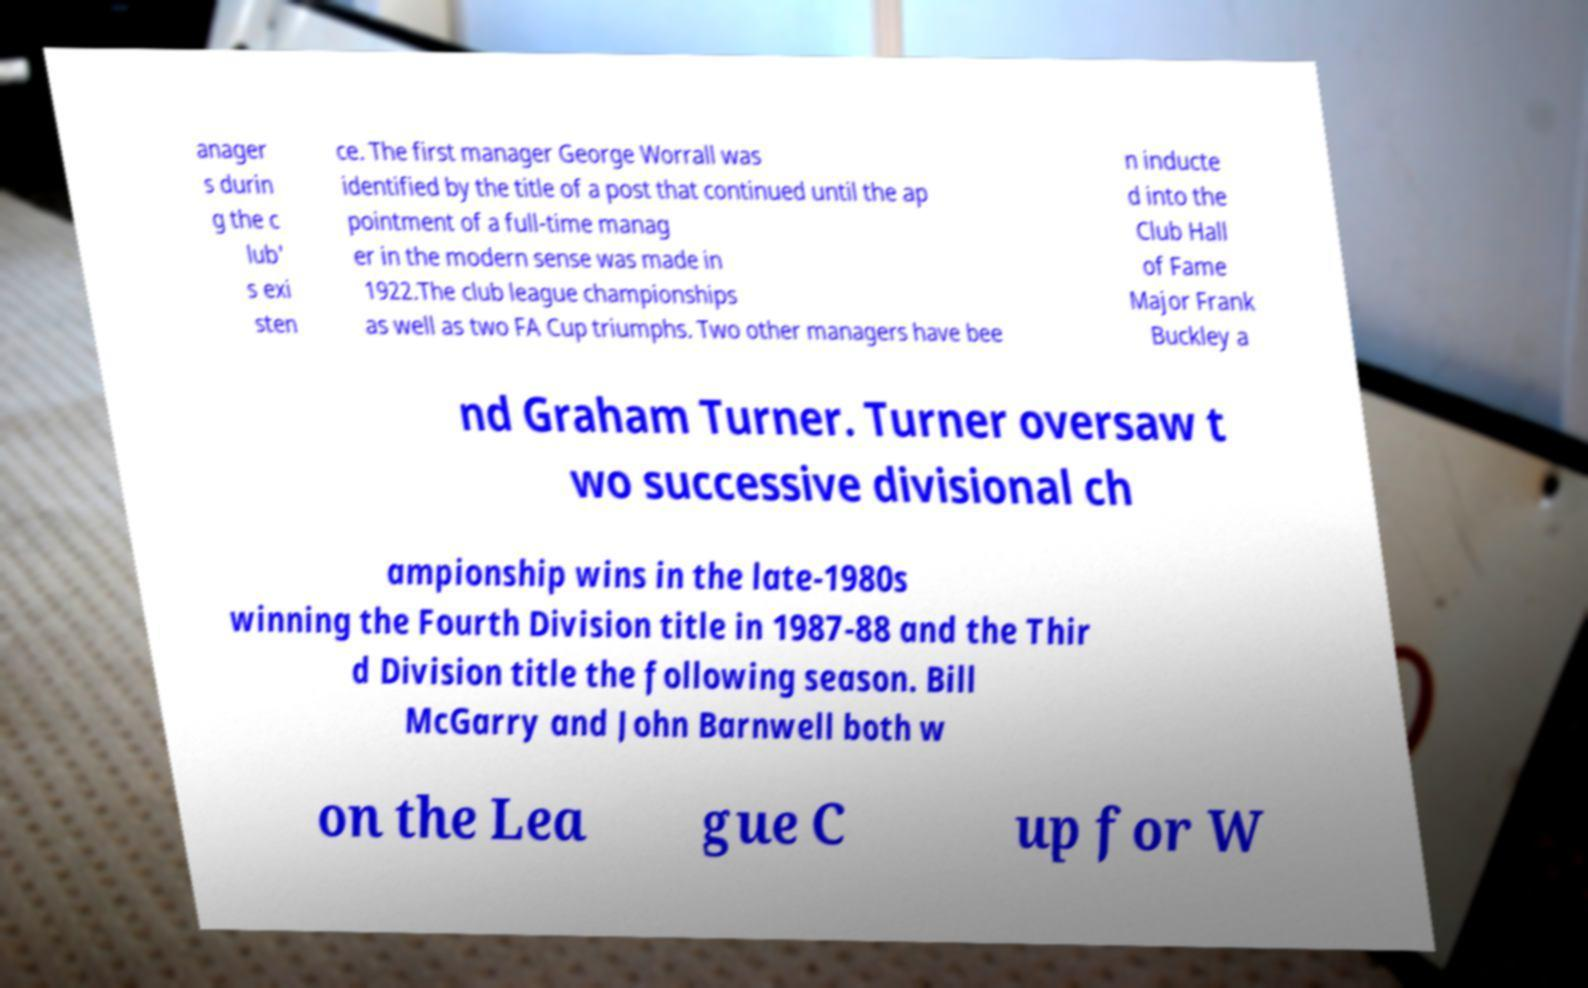What messages or text are displayed in this image? I need them in a readable, typed format. anager s durin g the c lub' s exi sten ce. The first manager George Worrall was identified by the title of a post that continued until the ap pointment of a full-time manag er in the modern sense was made in 1922.The club league championships as well as two FA Cup triumphs. Two other managers have bee n inducte d into the Club Hall of Fame Major Frank Buckley a nd Graham Turner. Turner oversaw t wo successive divisional ch ampionship wins in the late-1980s winning the Fourth Division title in 1987-88 and the Thir d Division title the following season. Bill McGarry and John Barnwell both w on the Lea gue C up for W 